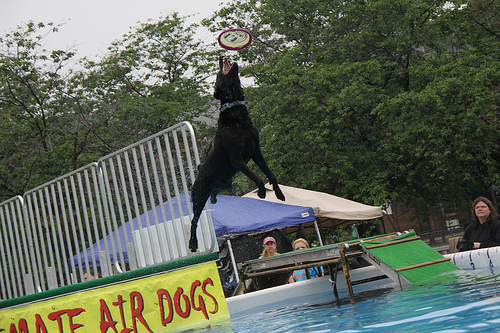<image>
Is there a frisbee in the sky? Yes. The frisbee is contained within or inside the sky, showing a containment relationship. 